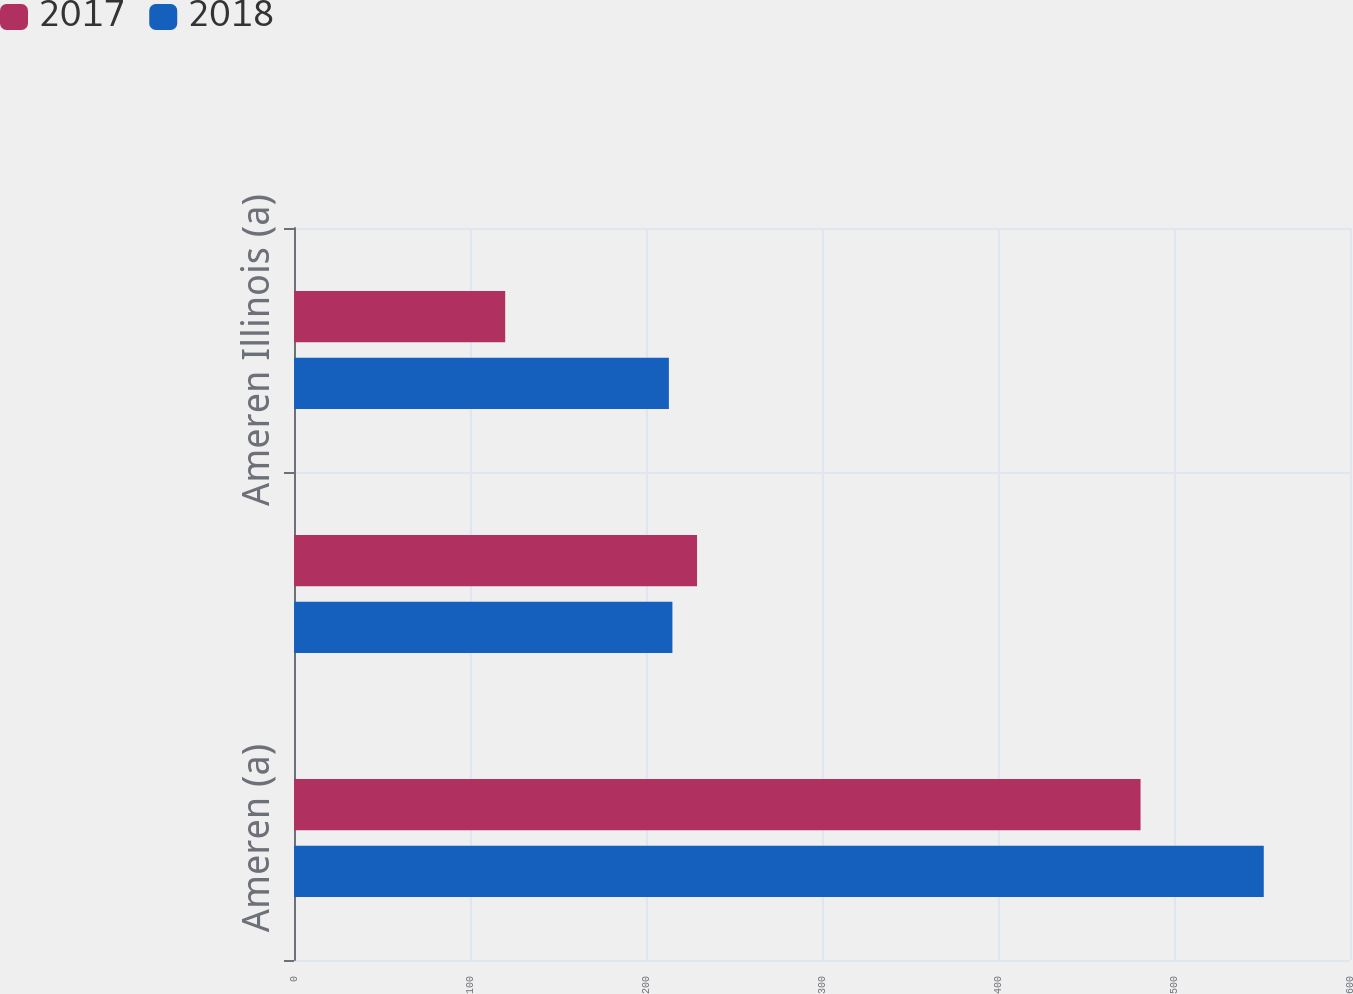Convert chart to OTSL. <chart><loc_0><loc_0><loc_500><loc_500><stacked_bar_chart><ecel><fcel>Ameren (a)<fcel>Ameren Missouri<fcel>Ameren Illinois (a)<nl><fcel>2017<fcel>481<fcel>229<fcel>120<nl><fcel>2018<fcel>551<fcel>215<fcel>213<nl></chart> 